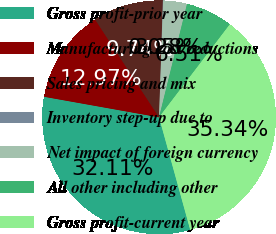Convert chart to OTSL. <chart><loc_0><loc_0><loc_500><loc_500><pie_chart><fcel>Gross profit-prior year<fcel>Manufacturing cost reductions<fcel>Sales pricing and mix<fcel>Inventory step-up due to<fcel>Net impact of foreign currency<fcel>All other including other<fcel>Gross profit-current year<nl><fcel>32.12%<fcel>12.97%<fcel>9.74%<fcel>0.05%<fcel>3.28%<fcel>6.51%<fcel>35.35%<nl></chart> 